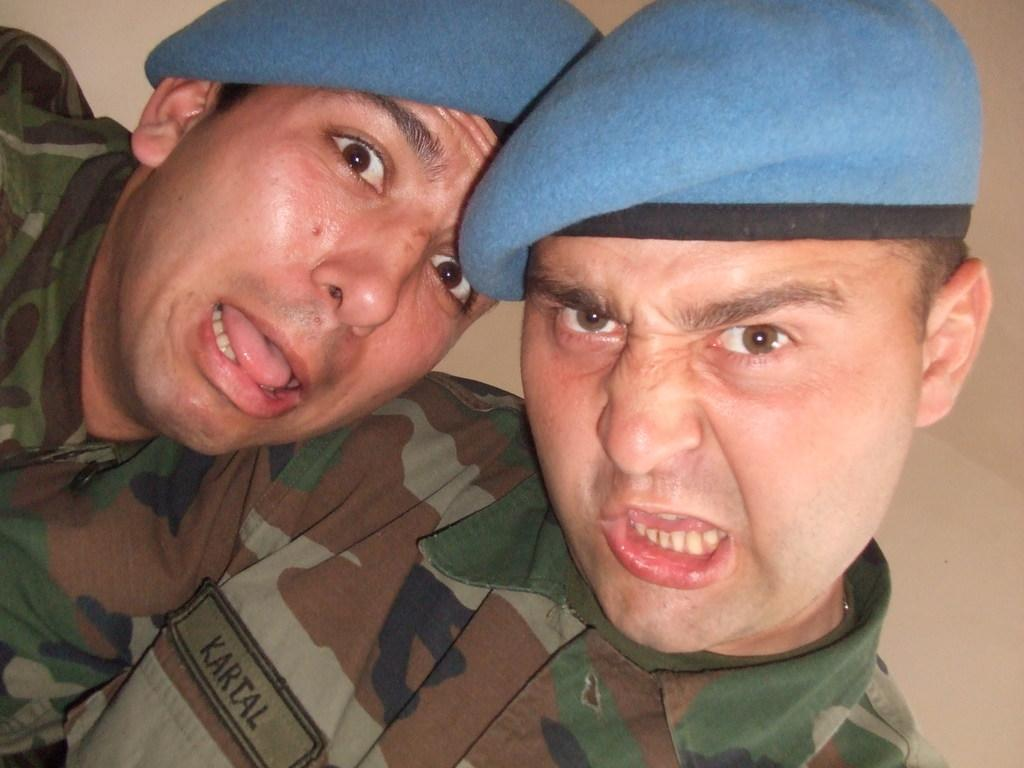How many people are in the image? There are two men in the image. Where are the men located in the image? The men are in the front of the image. What are the men wearing on their heads? The men are wearing caps. What can be seen in the background of the image? There is a wall in the background of the image. What type of tools is the kitten using to help the men in the image? There is no kitten present in the image, so it cannot be determined what tools it might be using. 